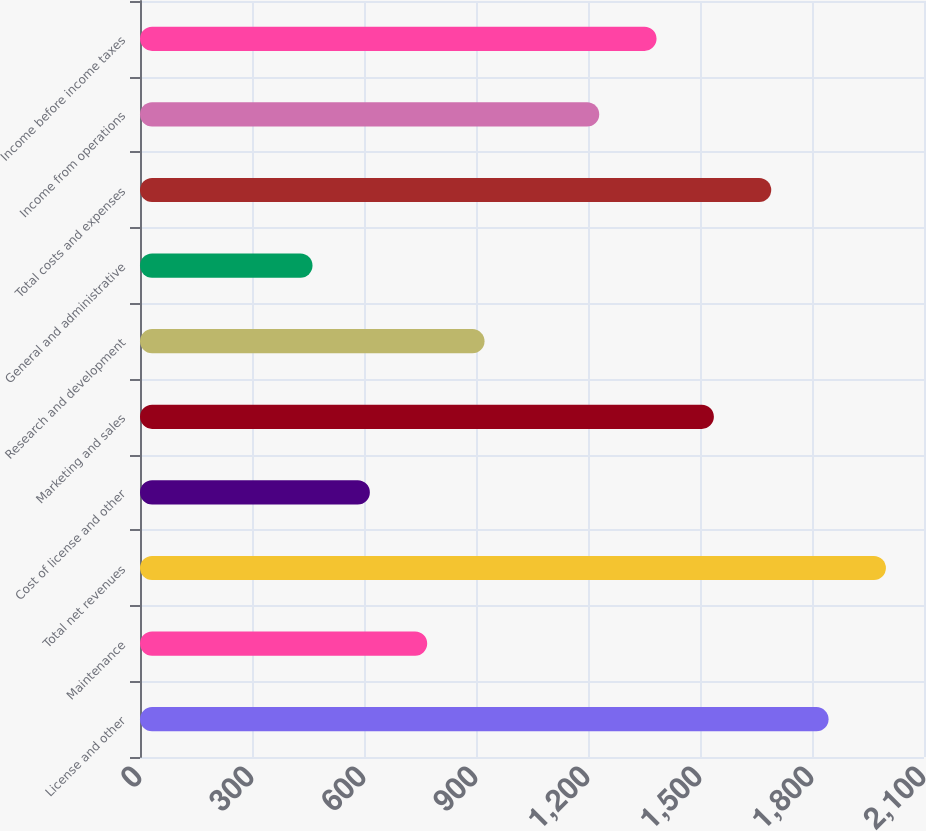Convert chart. <chart><loc_0><loc_0><loc_500><loc_500><bar_chart><fcel>License and other<fcel>Maintenance<fcel>Total net revenues<fcel>Cost of license and other<fcel>Marketing and sales<fcel>Research and development<fcel>General and administrative<fcel>Total costs and expenses<fcel>Income from operations<fcel>Income before income taxes<nl><fcel>1844.39<fcel>769.29<fcel>1997.98<fcel>615.7<fcel>1537.22<fcel>922.88<fcel>462.11<fcel>1690.81<fcel>1230.05<fcel>1383.63<nl></chart> 